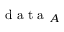Convert formula to latex. <formula><loc_0><loc_0><loc_500><loc_500>d a t a _ { A }</formula> 